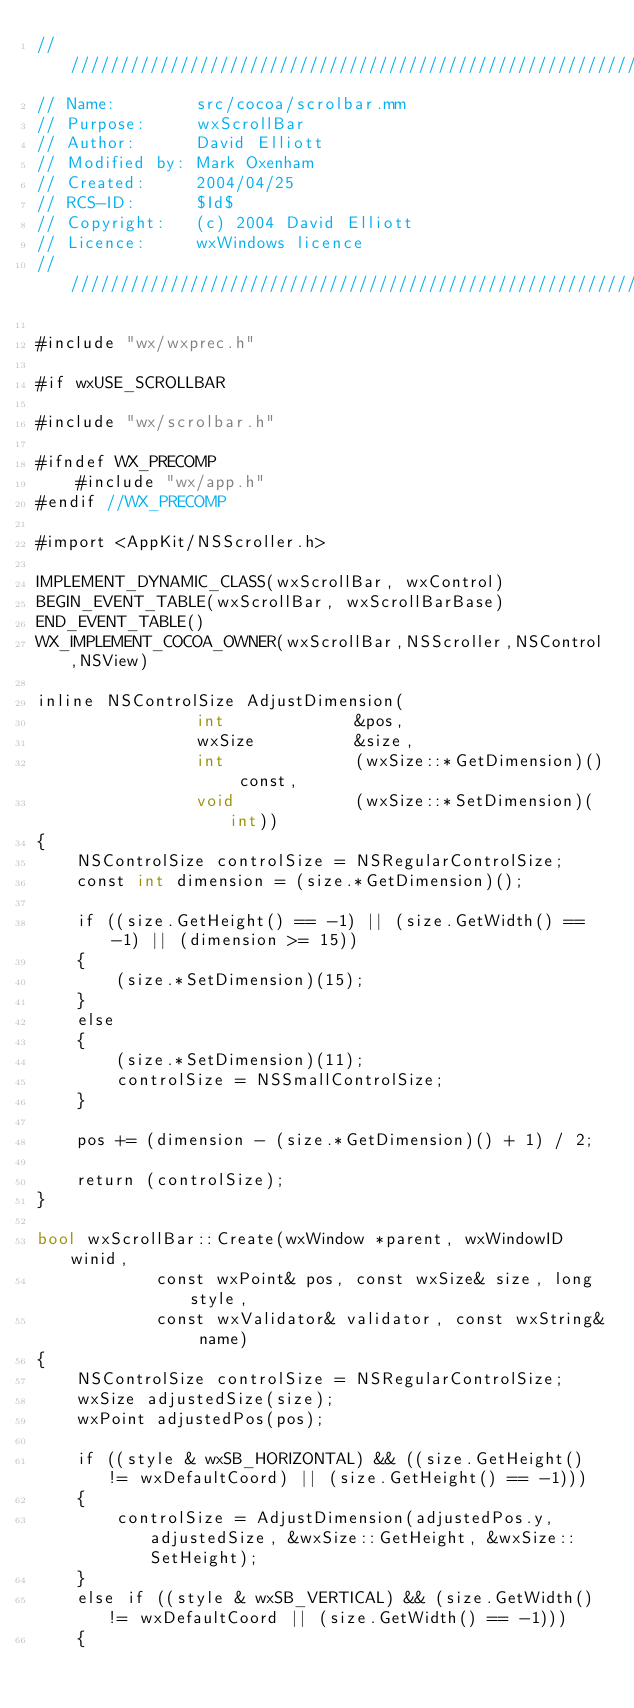<code> <loc_0><loc_0><loc_500><loc_500><_ObjectiveC_>/////////////////////////////////////////////////////////////////////////////
// Name:        src/cocoa/scrolbar.mm
// Purpose:     wxScrollBar
// Author:      David Elliott
// Modified by: Mark Oxenham
// Created:     2004/04/25
// RCS-ID:      $Id$
// Copyright:   (c) 2004 David Elliott
// Licence:     wxWindows licence
/////////////////////////////////////////////////////////////////////////////

#include "wx/wxprec.h"

#if wxUSE_SCROLLBAR

#include "wx/scrolbar.h"

#ifndef WX_PRECOMP
    #include "wx/app.h"
#endif //WX_PRECOMP

#import <AppKit/NSScroller.h>

IMPLEMENT_DYNAMIC_CLASS(wxScrollBar, wxControl)
BEGIN_EVENT_TABLE(wxScrollBar, wxScrollBarBase)
END_EVENT_TABLE()
WX_IMPLEMENT_COCOA_OWNER(wxScrollBar,NSScroller,NSControl,NSView)

inline NSControlSize AdjustDimension(
                int             &pos,
                wxSize          &size,
                int             (wxSize::*GetDimension)() const,
                void            (wxSize::*SetDimension)(int))
{
    NSControlSize controlSize = NSRegularControlSize;
    const int dimension = (size.*GetDimension)();

    if ((size.GetHeight() == -1) || (size.GetWidth() == -1) || (dimension >= 15)) 
    {
        (size.*SetDimension)(15);
    }
    else
    {
        (size.*SetDimension)(11);
        controlSize = NSSmallControlSize;
    }

    pos += (dimension - (size.*GetDimension)() + 1) / 2;

    return (controlSize);
}

bool wxScrollBar::Create(wxWindow *parent, wxWindowID winid,
            const wxPoint& pos, const wxSize& size, long style,
            const wxValidator& validator, const wxString& name)
{
    NSControlSize controlSize = NSRegularControlSize;
    wxSize adjustedSize(size);
    wxPoint adjustedPos(pos);

    if ((style & wxSB_HORIZONTAL) && ((size.GetHeight() != wxDefaultCoord) || (size.GetHeight() == -1)))
    {
        controlSize = AdjustDimension(adjustedPos.y, adjustedSize, &wxSize::GetHeight, &wxSize::SetHeight);
    }
    else if ((style & wxSB_VERTICAL) && (size.GetWidth() != wxDefaultCoord || (size.GetWidth() == -1)))
    {</code> 